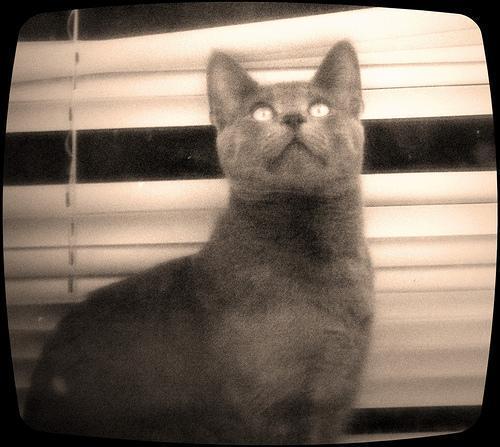How many cats are there?
Give a very brief answer. 1. 